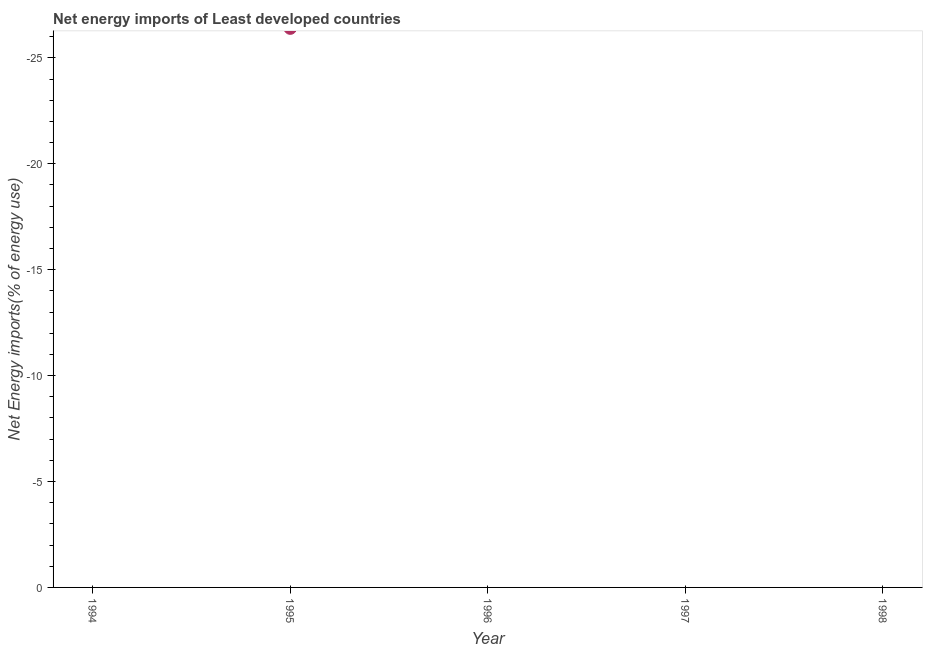What is the average energy imports per year?
Your response must be concise. 0. In how many years, is the energy imports greater than -15 %?
Your response must be concise. 0. Does the energy imports monotonically increase over the years?
Offer a very short reply. No. What is the difference between two consecutive major ticks on the Y-axis?
Your answer should be compact. 5. Does the graph contain any zero values?
Provide a short and direct response. Yes. Does the graph contain grids?
Keep it short and to the point. No. What is the title of the graph?
Give a very brief answer. Net energy imports of Least developed countries. What is the label or title of the X-axis?
Offer a terse response. Year. What is the label or title of the Y-axis?
Offer a very short reply. Net Energy imports(% of energy use). What is the Net Energy imports(% of energy use) in 1994?
Offer a very short reply. 0. What is the Net Energy imports(% of energy use) in 1995?
Offer a terse response. 0. 